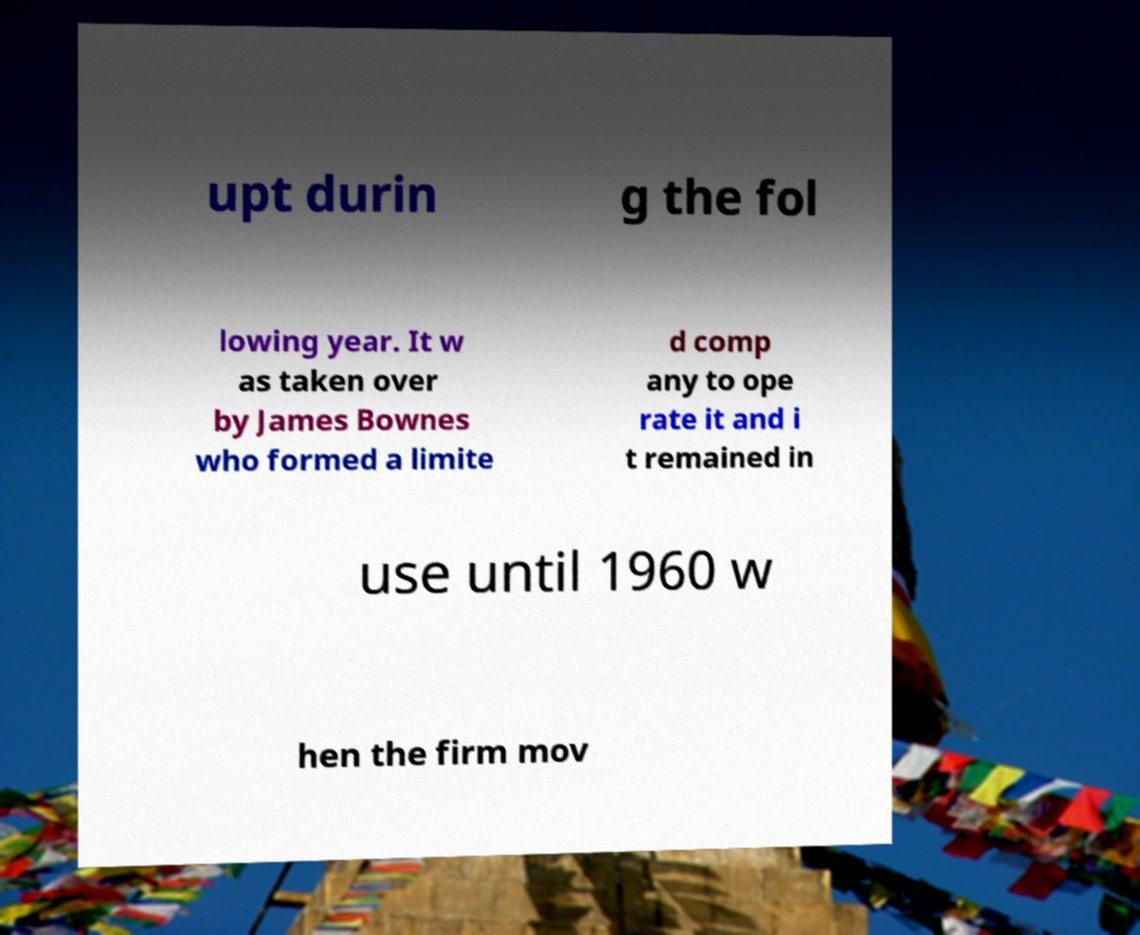Can you read and provide the text displayed in the image?This photo seems to have some interesting text. Can you extract and type it out for me? upt durin g the fol lowing year. It w as taken over by James Bownes who formed a limite d comp any to ope rate it and i t remained in use until 1960 w hen the firm mov 